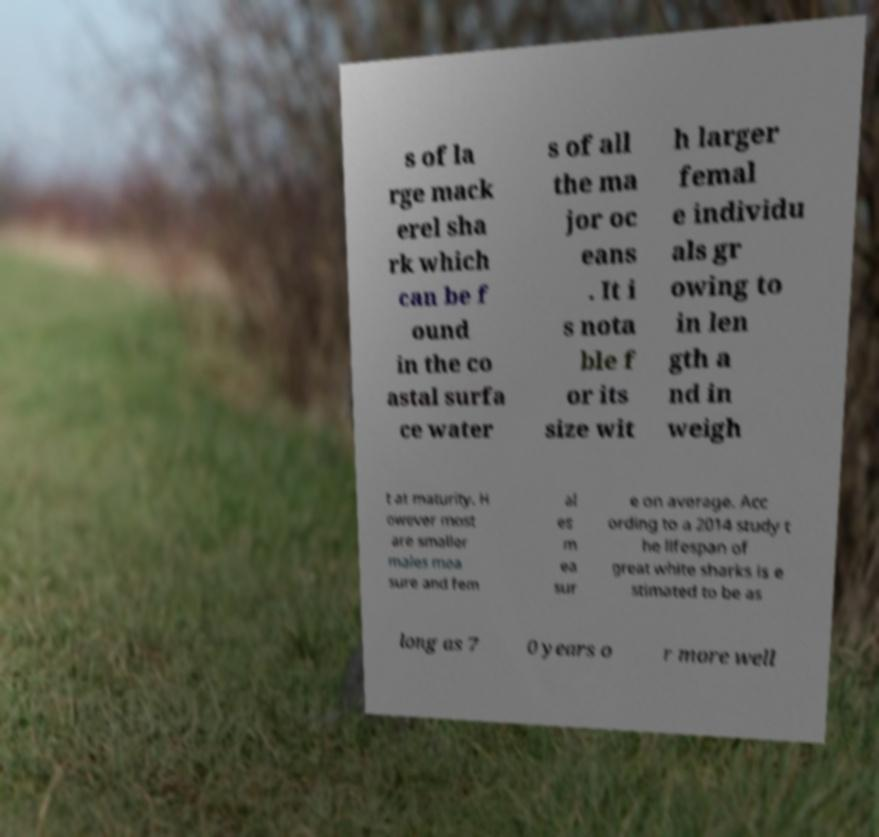Could you assist in decoding the text presented in this image and type it out clearly? s of la rge mack erel sha rk which can be f ound in the co astal surfa ce water s of all the ma jor oc eans . It i s nota ble f or its size wit h larger femal e individu als gr owing to in len gth a nd in weigh t at maturity. H owever most are smaller males mea sure and fem al es m ea sur e on average. Acc ording to a 2014 study t he lifespan of great white sharks is e stimated to be as long as 7 0 years o r more well 